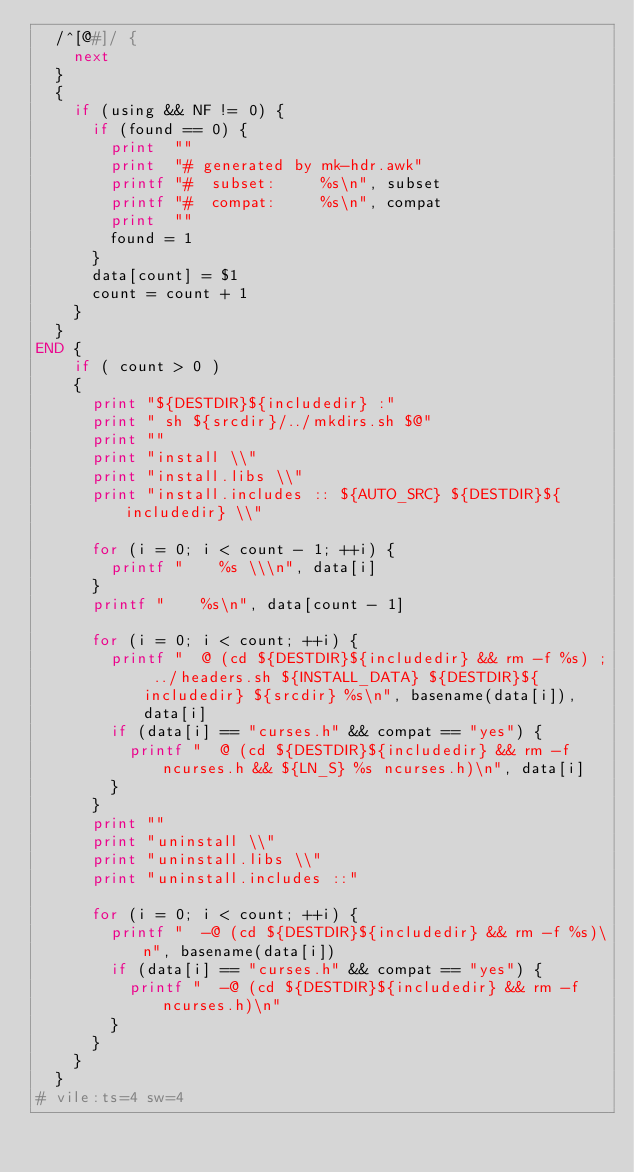Convert code to text. <code><loc_0><loc_0><loc_500><loc_500><_Awk_>	/^[@#]/ {
		next
	}
	{
		if (using && NF != 0) {
			if (found == 0) {
				print  ""
				print  "# generated by mk-hdr.awk"
				printf "#  subset:     %s\n", subset 
				printf "#  compat:     %s\n", compat 
				print  ""
				found = 1
			}
			data[count] = $1
			count = count + 1
		}
	}
END	{
		if ( count > 0 )
		{
			print "${DESTDIR}${includedir} :"
			print "	sh ${srcdir}/../mkdirs.sh $@"
			print ""
			print "install \\"
			print "install.libs \\"
			print "install.includes :: ${AUTO_SRC} ${DESTDIR}${includedir} \\"

			for (i = 0; i < count - 1; ++i) {
				printf "		%s \\\n", data[i]
			}
			printf "		%s\n", data[count - 1]

			for (i = 0; i < count; ++i) {
				printf "	@ (cd ${DESTDIR}${includedir} && rm -f %s) ; ../headers.sh ${INSTALL_DATA} ${DESTDIR}${includedir} ${srcdir} %s\n", basename(data[i]), data[i]
				if (data[i] == "curses.h" && compat == "yes") {
					printf "	@ (cd ${DESTDIR}${includedir} && rm -f ncurses.h && ${LN_S} %s ncurses.h)\n", data[i]
				}
			}
			print ""
			print "uninstall \\"
			print "uninstall.libs \\"
			print "uninstall.includes ::"

			for (i = 0; i < count; ++i) {
				printf "	-@ (cd ${DESTDIR}${includedir} && rm -f %s)\n", basename(data[i])
				if (data[i] == "curses.h" && compat == "yes") {
					printf "	-@ (cd ${DESTDIR}${includedir} && rm -f ncurses.h)\n"
				}
			}
		}
	}
# vile:ts=4 sw=4
</code> 